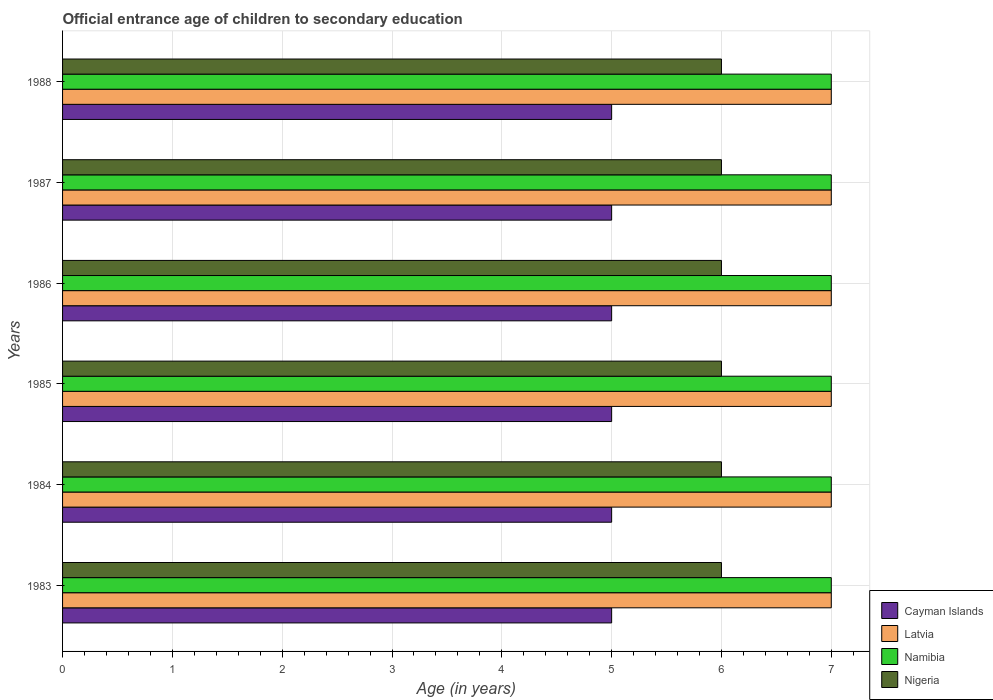How many different coloured bars are there?
Provide a succinct answer. 4. How many bars are there on the 5th tick from the bottom?
Your answer should be very brief. 4. In how many cases, is the number of bars for a given year not equal to the number of legend labels?
Provide a short and direct response. 0. What is the secondary school starting age of children in Cayman Islands in 1983?
Provide a short and direct response. 5. Across all years, what is the maximum secondary school starting age of children in Namibia?
Your response must be concise. 7. In which year was the secondary school starting age of children in Latvia minimum?
Provide a short and direct response. 1983. What is the total secondary school starting age of children in Latvia in the graph?
Your answer should be very brief. 42. What is the difference between the secondary school starting age of children in Cayman Islands in 1987 and the secondary school starting age of children in Namibia in 1985?
Your answer should be compact. -2. What is the average secondary school starting age of children in Latvia per year?
Your answer should be very brief. 7. What is the ratio of the secondary school starting age of children in Namibia in 1985 to that in 1986?
Ensure brevity in your answer.  1. Is the sum of the secondary school starting age of children in Latvia in 1987 and 1988 greater than the maximum secondary school starting age of children in Namibia across all years?
Make the answer very short. Yes. Is it the case that in every year, the sum of the secondary school starting age of children in Latvia and secondary school starting age of children in Nigeria is greater than the sum of secondary school starting age of children in Cayman Islands and secondary school starting age of children in Namibia?
Keep it short and to the point. No. What does the 1st bar from the top in 1988 represents?
Offer a very short reply. Nigeria. What does the 1st bar from the bottom in 1984 represents?
Make the answer very short. Cayman Islands. How many bars are there?
Keep it short and to the point. 24. Are all the bars in the graph horizontal?
Your response must be concise. Yes. How many years are there in the graph?
Give a very brief answer. 6. Are the values on the major ticks of X-axis written in scientific E-notation?
Offer a very short reply. No. Does the graph contain any zero values?
Provide a succinct answer. No. Does the graph contain grids?
Ensure brevity in your answer.  Yes. Where does the legend appear in the graph?
Give a very brief answer. Bottom right. How many legend labels are there?
Keep it short and to the point. 4. What is the title of the graph?
Give a very brief answer. Official entrance age of children to secondary education. Does "Bhutan" appear as one of the legend labels in the graph?
Offer a very short reply. No. What is the label or title of the X-axis?
Provide a short and direct response. Age (in years). What is the label or title of the Y-axis?
Make the answer very short. Years. What is the Age (in years) in Cayman Islands in 1983?
Keep it short and to the point. 5. What is the Age (in years) in Latvia in 1983?
Make the answer very short. 7. What is the Age (in years) of Latvia in 1984?
Keep it short and to the point. 7. What is the Age (in years) of Latvia in 1985?
Your answer should be very brief. 7. What is the Age (in years) in Latvia in 1986?
Provide a short and direct response. 7. What is the Age (in years) of Nigeria in 1986?
Your answer should be very brief. 6. What is the Age (in years) of Cayman Islands in 1987?
Ensure brevity in your answer.  5. What is the Age (in years) in Latvia in 1988?
Provide a short and direct response. 7. Across all years, what is the maximum Age (in years) in Latvia?
Make the answer very short. 7. Across all years, what is the maximum Age (in years) of Nigeria?
Your answer should be compact. 6. Across all years, what is the minimum Age (in years) of Latvia?
Keep it short and to the point. 7. Across all years, what is the minimum Age (in years) of Nigeria?
Your answer should be compact. 6. What is the total Age (in years) of Cayman Islands in the graph?
Give a very brief answer. 30. What is the total Age (in years) of Nigeria in the graph?
Make the answer very short. 36. What is the difference between the Age (in years) of Cayman Islands in 1983 and that in 1985?
Provide a short and direct response. 0. What is the difference between the Age (in years) in Latvia in 1983 and that in 1985?
Provide a short and direct response. 0. What is the difference between the Age (in years) of Namibia in 1983 and that in 1985?
Ensure brevity in your answer.  0. What is the difference between the Age (in years) in Cayman Islands in 1983 and that in 1986?
Offer a terse response. 0. What is the difference between the Age (in years) of Nigeria in 1983 and that in 1986?
Keep it short and to the point. 0. What is the difference between the Age (in years) of Latvia in 1983 and that in 1987?
Ensure brevity in your answer.  0. What is the difference between the Age (in years) in Namibia in 1983 and that in 1987?
Give a very brief answer. 0. What is the difference between the Age (in years) in Cayman Islands in 1983 and that in 1988?
Make the answer very short. 0. What is the difference between the Age (in years) in Latvia in 1983 and that in 1988?
Keep it short and to the point. 0. What is the difference between the Age (in years) in Namibia in 1983 and that in 1988?
Ensure brevity in your answer.  0. What is the difference between the Age (in years) in Nigeria in 1983 and that in 1988?
Ensure brevity in your answer.  0. What is the difference between the Age (in years) in Cayman Islands in 1984 and that in 1986?
Ensure brevity in your answer.  0. What is the difference between the Age (in years) in Nigeria in 1984 and that in 1986?
Offer a very short reply. 0. What is the difference between the Age (in years) in Cayman Islands in 1984 and that in 1987?
Your answer should be very brief. 0. What is the difference between the Age (in years) of Latvia in 1984 and that in 1987?
Offer a terse response. 0. What is the difference between the Age (in years) of Nigeria in 1984 and that in 1987?
Keep it short and to the point. 0. What is the difference between the Age (in years) in Cayman Islands in 1984 and that in 1988?
Make the answer very short. 0. What is the difference between the Age (in years) of Namibia in 1984 and that in 1988?
Ensure brevity in your answer.  0. What is the difference between the Age (in years) of Nigeria in 1984 and that in 1988?
Your response must be concise. 0. What is the difference between the Age (in years) in Cayman Islands in 1985 and that in 1986?
Your answer should be very brief. 0. What is the difference between the Age (in years) in Latvia in 1985 and that in 1986?
Offer a terse response. 0. What is the difference between the Age (in years) in Namibia in 1985 and that in 1986?
Provide a succinct answer. 0. What is the difference between the Age (in years) of Nigeria in 1985 and that in 1986?
Your answer should be very brief. 0. What is the difference between the Age (in years) in Latvia in 1985 and that in 1987?
Give a very brief answer. 0. What is the difference between the Age (in years) in Latvia in 1985 and that in 1988?
Your response must be concise. 0. What is the difference between the Age (in years) of Nigeria in 1985 and that in 1988?
Provide a succinct answer. 0. What is the difference between the Age (in years) in Cayman Islands in 1986 and that in 1987?
Provide a short and direct response. 0. What is the difference between the Age (in years) of Latvia in 1986 and that in 1987?
Give a very brief answer. 0. What is the difference between the Age (in years) of Namibia in 1986 and that in 1987?
Your answer should be very brief. 0. What is the difference between the Age (in years) of Nigeria in 1986 and that in 1988?
Make the answer very short. 0. What is the difference between the Age (in years) of Latvia in 1987 and that in 1988?
Ensure brevity in your answer.  0. What is the difference between the Age (in years) in Namibia in 1987 and that in 1988?
Offer a very short reply. 0. What is the difference between the Age (in years) of Cayman Islands in 1983 and the Age (in years) of Latvia in 1984?
Your answer should be very brief. -2. What is the difference between the Age (in years) in Cayman Islands in 1983 and the Age (in years) in Namibia in 1984?
Keep it short and to the point. -2. What is the difference between the Age (in years) in Latvia in 1983 and the Age (in years) in Namibia in 1984?
Ensure brevity in your answer.  0. What is the difference between the Age (in years) of Cayman Islands in 1983 and the Age (in years) of Latvia in 1985?
Give a very brief answer. -2. What is the difference between the Age (in years) of Cayman Islands in 1983 and the Age (in years) of Namibia in 1985?
Make the answer very short. -2. What is the difference between the Age (in years) of Latvia in 1983 and the Age (in years) of Namibia in 1985?
Keep it short and to the point. 0. What is the difference between the Age (in years) of Cayman Islands in 1983 and the Age (in years) of Nigeria in 1986?
Offer a very short reply. -1. What is the difference between the Age (in years) in Namibia in 1983 and the Age (in years) in Nigeria in 1986?
Provide a succinct answer. 1. What is the difference between the Age (in years) in Cayman Islands in 1983 and the Age (in years) in Nigeria in 1987?
Provide a succinct answer. -1. What is the difference between the Age (in years) of Latvia in 1983 and the Age (in years) of Namibia in 1987?
Offer a terse response. 0. What is the difference between the Age (in years) of Cayman Islands in 1983 and the Age (in years) of Latvia in 1988?
Keep it short and to the point. -2. What is the difference between the Age (in years) in Cayman Islands in 1983 and the Age (in years) in Namibia in 1988?
Provide a succinct answer. -2. What is the difference between the Age (in years) of Cayman Islands in 1984 and the Age (in years) of Latvia in 1985?
Your answer should be compact. -2. What is the difference between the Age (in years) of Cayman Islands in 1984 and the Age (in years) of Namibia in 1985?
Offer a terse response. -2. What is the difference between the Age (in years) in Cayman Islands in 1984 and the Age (in years) in Nigeria in 1985?
Your response must be concise. -1. What is the difference between the Age (in years) of Latvia in 1984 and the Age (in years) of Namibia in 1985?
Your answer should be compact. 0. What is the difference between the Age (in years) of Cayman Islands in 1984 and the Age (in years) of Latvia in 1986?
Offer a very short reply. -2. What is the difference between the Age (in years) of Cayman Islands in 1984 and the Age (in years) of Nigeria in 1986?
Provide a short and direct response. -1. What is the difference between the Age (in years) in Cayman Islands in 1984 and the Age (in years) in Latvia in 1987?
Give a very brief answer. -2. What is the difference between the Age (in years) in Cayman Islands in 1984 and the Age (in years) in Nigeria in 1987?
Your answer should be compact. -1. What is the difference between the Age (in years) in Latvia in 1984 and the Age (in years) in Namibia in 1987?
Make the answer very short. 0. What is the difference between the Age (in years) in Latvia in 1984 and the Age (in years) in Nigeria in 1987?
Your response must be concise. 1. What is the difference between the Age (in years) of Cayman Islands in 1984 and the Age (in years) of Latvia in 1988?
Provide a succinct answer. -2. What is the difference between the Age (in years) of Cayman Islands in 1984 and the Age (in years) of Namibia in 1988?
Your answer should be compact. -2. What is the difference between the Age (in years) in Cayman Islands in 1984 and the Age (in years) in Nigeria in 1988?
Offer a terse response. -1. What is the difference between the Age (in years) of Latvia in 1984 and the Age (in years) of Nigeria in 1988?
Keep it short and to the point. 1. What is the difference between the Age (in years) of Cayman Islands in 1985 and the Age (in years) of Nigeria in 1986?
Offer a terse response. -1. What is the difference between the Age (in years) in Latvia in 1985 and the Age (in years) in Namibia in 1986?
Provide a short and direct response. 0. What is the difference between the Age (in years) in Namibia in 1985 and the Age (in years) in Nigeria in 1986?
Your response must be concise. 1. What is the difference between the Age (in years) of Cayman Islands in 1985 and the Age (in years) of Latvia in 1987?
Your answer should be very brief. -2. What is the difference between the Age (in years) in Latvia in 1985 and the Age (in years) in Nigeria in 1987?
Keep it short and to the point. 1. What is the difference between the Age (in years) in Namibia in 1985 and the Age (in years) in Nigeria in 1987?
Keep it short and to the point. 1. What is the difference between the Age (in years) in Cayman Islands in 1985 and the Age (in years) in Latvia in 1988?
Give a very brief answer. -2. What is the difference between the Age (in years) of Latvia in 1985 and the Age (in years) of Nigeria in 1988?
Your answer should be very brief. 1. What is the difference between the Age (in years) in Cayman Islands in 1986 and the Age (in years) in Namibia in 1987?
Provide a succinct answer. -2. What is the difference between the Age (in years) in Latvia in 1986 and the Age (in years) in Namibia in 1987?
Offer a terse response. 0. What is the difference between the Age (in years) in Latvia in 1986 and the Age (in years) in Nigeria in 1987?
Keep it short and to the point. 1. What is the difference between the Age (in years) in Namibia in 1986 and the Age (in years) in Nigeria in 1987?
Offer a very short reply. 1. What is the difference between the Age (in years) of Cayman Islands in 1987 and the Age (in years) of Latvia in 1988?
Your answer should be very brief. -2. What is the difference between the Age (in years) of Cayman Islands in 1987 and the Age (in years) of Namibia in 1988?
Give a very brief answer. -2. What is the difference between the Age (in years) in Cayman Islands in 1987 and the Age (in years) in Nigeria in 1988?
Offer a terse response. -1. What is the difference between the Age (in years) in Namibia in 1987 and the Age (in years) in Nigeria in 1988?
Offer a very short reply. 1. What is the average Age (in years) in Latvia per year?
Your answer should be very brief. 7. In the year 1983, what is the difference between the Age (in years) of Cayman Islands and Age (in years) of Nigeria?
Give a very brief answer. -1. In the year 1983, what is the difference between the Age (in years) in Latvia and Age (in years) in Namibia?
Give a very brief answer. 0. In the year 1983, what is the difference between the Age (in years) in Latvia and Age (in years) in Nigeria?
Provide a succinct answer. 1. In the year 1983, what is the difference between the Age (in years) of Namibia and Age (in years) of Nigeria?
Offer a terse response. 1. In the year 1984, what is the difference between the Age (in years) of Cayman Islands and Age (in years) of Nigeria?
Offer a terse response. -1. In the year 1985, what is the difference between the Age (in years) of Latvia and Age (in years) of Namibia?
Offer a very short reply. 0. In the year 1986, what is the difference between the Age (in years) in Cayman Islands and Age (in years) in Latvia?
Your answer should be very brief. -2. In the year 1986, what is the difference between the Age (in years) in Cayman Islands and Age (in years) in Namibia?
Make the answer very short. -2. In the year 1986, what is the difference between the Age (in years) in Namibia and Age (in years) in Nigeria?
Your response must be concise. 1. In the year 1987, what is the difference between the Age (in years) of Cayman Islands and Age (in years) of Latvia?
Ensure brevity in your answer.  -2. In the year 1987, what is the difference between the Age (in years) of Cayman Islands and Age (in years) of Namibia?
Keep it short and to the point. -2. In the year 1987, what is the difference between the Age (in years) of Latvia and Age (in years) of Namibia?
Give a very brief answer. 0. In the year 1987, what is the difference between the Age (in years) of Latvia and Age (in years) of Nigeria?
Ensure brevity in your answer.  1. In the year 1988, what is the difference between the Age (in years) in Cayman Islands and Age (in years) in Namibia?
Ensure brevity in your answer.  -2. In the year 1988, what is the difference between the Age (in years) in Cayman Islands and Age (in years) in Nigeria?
Your answer should be very brief. -1. In the year 1988, what is the difference between the Age (in years) of Latvia and Age (in years) of Namibia?
Ensure brevity in your answer.  0. In the year 1988, what is the difference between the Age (in years) in Latvia and Age (in years) in Nigeria?
Offer a very short reply. 1. In the year 1988, what is the difference between the Age (in years) of Namibia and Age (in years) of Nigeria?
Your answer should be very brief. 1. What is the ratio of the Age (in years) of Latvia in 1983 to that in 1984?
Your answer should be compact. 1. What is the ratio of the Age (in years) of Nigeria in 1983 to that in 1984?
Make the answer very short. 1. What is the ratio of the Age (in years) of Latvia in 1983 to that in 1985?
Offer a very short reply. 1. What is the ratio of the Age (in years) of Nigeria in 1983 to that in 1985?
Make the answer very short. 1. What is the ratio of the Age (in years) of Cayman Islands in 1983 to that in 1986?
Offer a very short reply. 1. What is the ratio of the Age (in years) of Latvia in 1983 to that in 1986?
Offer a terse response. 1. What is the ratio of the Age (in years) in Namibia in 1983 to that in 1986?
Your response must be concise. 1. What is the ratio of the Age (in years) in Nigeria in 1983 to that in 1986?
Your response must be concise. 1. What is the ratio of the Age (in years) of Cayman Islands in 1983 to that in 1987?
Offer a very short reply. 1. What is the ratio of the Age (in years) of Latvia in 1983 to that in 1987?
Keep it short and to the point. 1. What is the ratio of the Age (in years) of Nigeria in 1983 to that in 1988?
Ensure brevity in your answer.  1. What is the ratio of the Age (in years) of Cayman Islands in 1984 to that in 1985?
Provide a succinct answer. 1. What is the ratio of the Age (in years) in Latvia in 1984 to that in 1985?
Make the answer very short. 1. What is the ratio of the Age (in years) in Nigeria in 1984 to that in 1986?
Your answer should be compact. 1. What is the ratio of the Age (in years) of Latvia in 1984 to that in 1987?
Give a very brief answer. 1. What is the ratio of the Age (in years) of Nigeria in 1984 to that in 1988?
Offer a terse response. 1. What is the ratio of the Age (in years) in Cayman Islands in 1985 to that in 1986?
Make the answer very short. 1. What is the ratio of the Age (in years) in Namibia in 1985 to that in 1986?
Keep it short and to the point. 1. What is the ratio of the Age (in years) of Latvia in 1985 to that in 1987?
Make the answer very short. 1. What is the ratio of the Age (in years) in Namibia in 1985 to that in 1987?
Your response must be concise. 1. What is the ratio of the Age (in years) in Namibia in 1985 to that in 1988?
Your answer should be very brief. 1. What is the ratio of the Age (in years) of Cayman Islands in 1986 to that in 1987?
Offer a terse response. 1. What is the ratio of the Age (in years) in Namibia in 1986 to that in 1987?
Keep it short and to the point. 1. What is the ratio of the Age (in years) in Cayman Islands in 1986 to that in 1988?
Offer a very short reply. 1. What is the ratio of the Age (in years) in Latvia in 1986 to that in 1988?
Give a very brief answer. 1. What is the ratio of the Age (in years) of Nigeria in 1986 to that in 1988?
Provide a succinct answer. 1. What is the ratio of the Age (in years) of Latvia in 1987 to that in 1988?
Provide a short and direct response. 1. What is the ratio of the Age (in years) of Namibia in 1987 to that in 1988?
Offer a terse response. 1. What is the difference between the highest and the second highest Age (in years) of Cayman Islands?
Ensure brevity in your answer.  0. What is the difference between the highest and the second highest Age (in years) in Namibia?
Your response must be concise. 0. What is the difference between the highest and the lowest Age (in years) in Cayman Islands?
Keep it short and to the point. 0. 